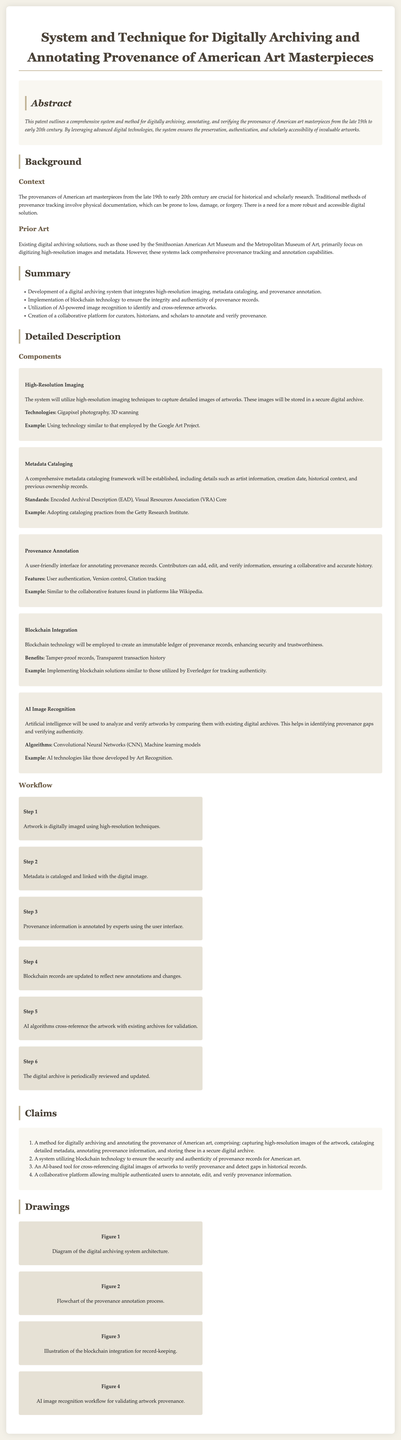What is the focused period for the American art masterpieces? The document specifies that it pertains to artworks from the late 19th to early 20th century.
Answer: late 19th to early 20th century What technology is used to ensure the authenticity of provenance records? The document mentions the utilization of blockchain technology for enhancing security and authenticity.
Answer: blockchain technology Which component captures detailed images of artworks? The high-resolution imaging component is described as capturing detailed images of artworks.
Answer: High-Resolution Imaging What standards are included in the metadata cataloging framework? The document lists Encoded Archival Description (EAD) and Visual Resources Association (VRA) Core as standards for metadata cataloging.
Answer: Encoded Archival Description, Visual Resources Association Core How many steps are there in the workflow of the digital archiving process? The workflow section outlines six distinct steps involved in the process.
Answer: 6 What AI technologies are mentioned for verifying artworks? The document specifies that Convolutional Neural Networks (CNN) and machine learning models will be used for image recognition.
Answer: Convolutional Neural Networks, Machine learning models What feature ensures a collaborative environment for provenance annotation? The document highlights user authentication and version control as features that facilitate collaboration among users.
Answer: User authentication, Version control Which museum is referenced for existing digital archiving solutions? The Smithsonian American Art Museum is noted as one of the institutions with current archiving solutions.
Answer: Smithsonian American Art Museum What is the purpose of the collaborative platform described in the document? The collaborative platform allows curators, historians, and scholars to annotate and verify provenance.
Answer: Annotate and verify provenance 